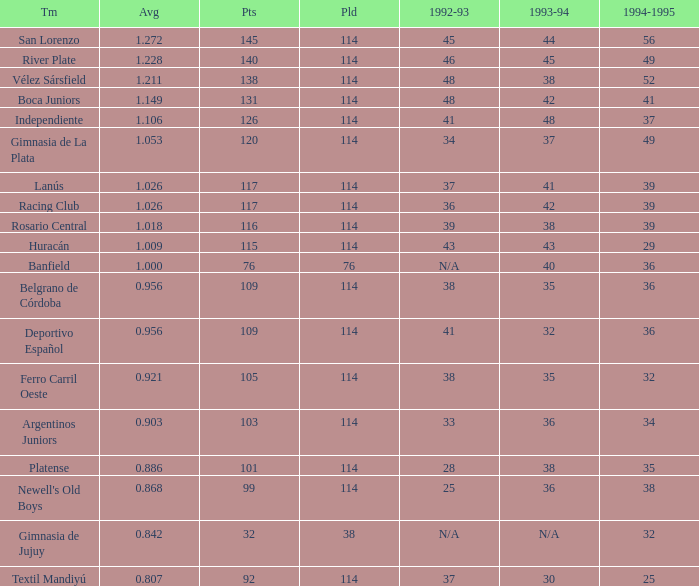Name the most played 114.0. 